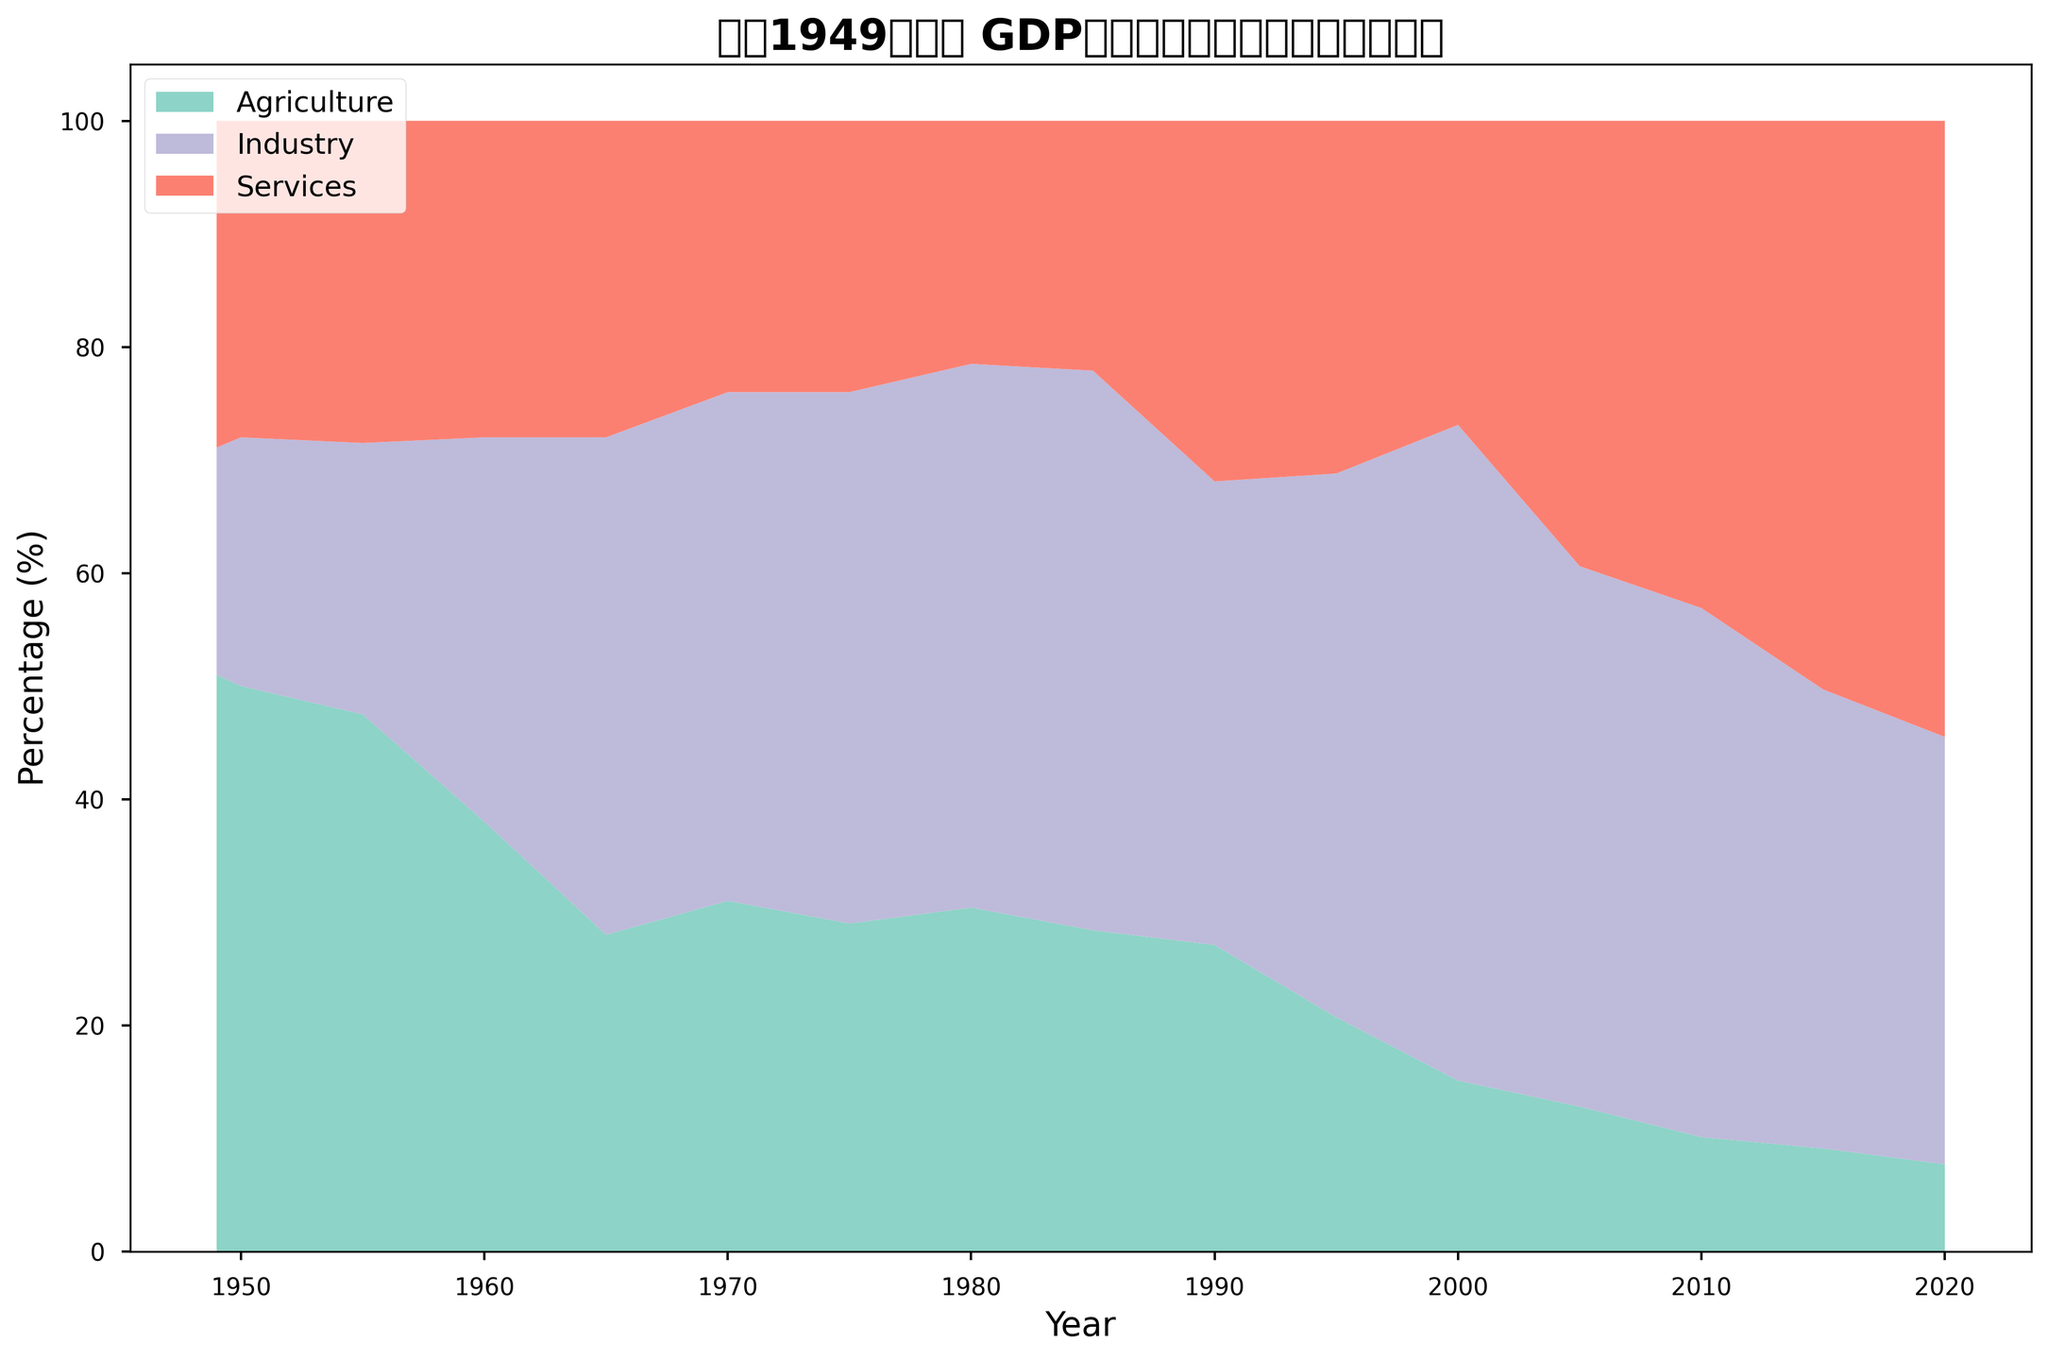什么行业在1949年贡献了最大的GDP比例？ 图中显示1949年农业占比51.0%，是最高的
Answer: 农业 1950年到1965年间哪一年工业对GDP的贡献率最高？ 从图中可见，1965年工业占比达到了44.0%，是1950年到1965年间最高的
Answer: 1965年 服务业对比农业和工业在2015年的GDP贡献率中占据了什么位置？ 服务业在2015年的GDP贡献率为50.3%，超过了农业的9.1%和工业的40.6%
Answer: 第一 1970年和1980年间，工业对GDP的贡献有没有增加？ 从图中数据可见，1970年工业占比为45.0%，1980年增至48.1%，显示了增加
Answer: 增加 将1980年和2010年的农业、工业和服务业比例相加，哪个年份的总值更高？ 1980年总值为30.4+48.1+21.5=100.0，2010年总值为10.1+46.8+43.1=100.0，两者总值一样
Answer: 相等 在2020年，哪个行业的比例最低？ 根据图表，2020年农业占比7.7%，是最低的
Answer: 农业 从1949年到2020年，哪一个行业的总增长最显著？ 从图中可以观察到服务业的增长最显著，从28.9%增至54.5%
Answer: 服务业 1990年工业和服务业的比例差是多少？ 图中显示1990年工业占比41.0%，服务业占比31.9%，差为41.0%-31.9%=9.1%
Answer: 9.1% 比较2000年和2015年，哪个年份的农业占比更低？ 图表显示2000年农业占比为15.1%，2015年为9.1%，2015年更低
Answer: 2015年 1995年到2020年，农业和工业的比例有没有逐年减少？ 从图中看，1995年农业占比20.7%，2020年降至7.7%，工业从48.1%降至37.8%，均显示逐年减少的趋势
Answer: 是 